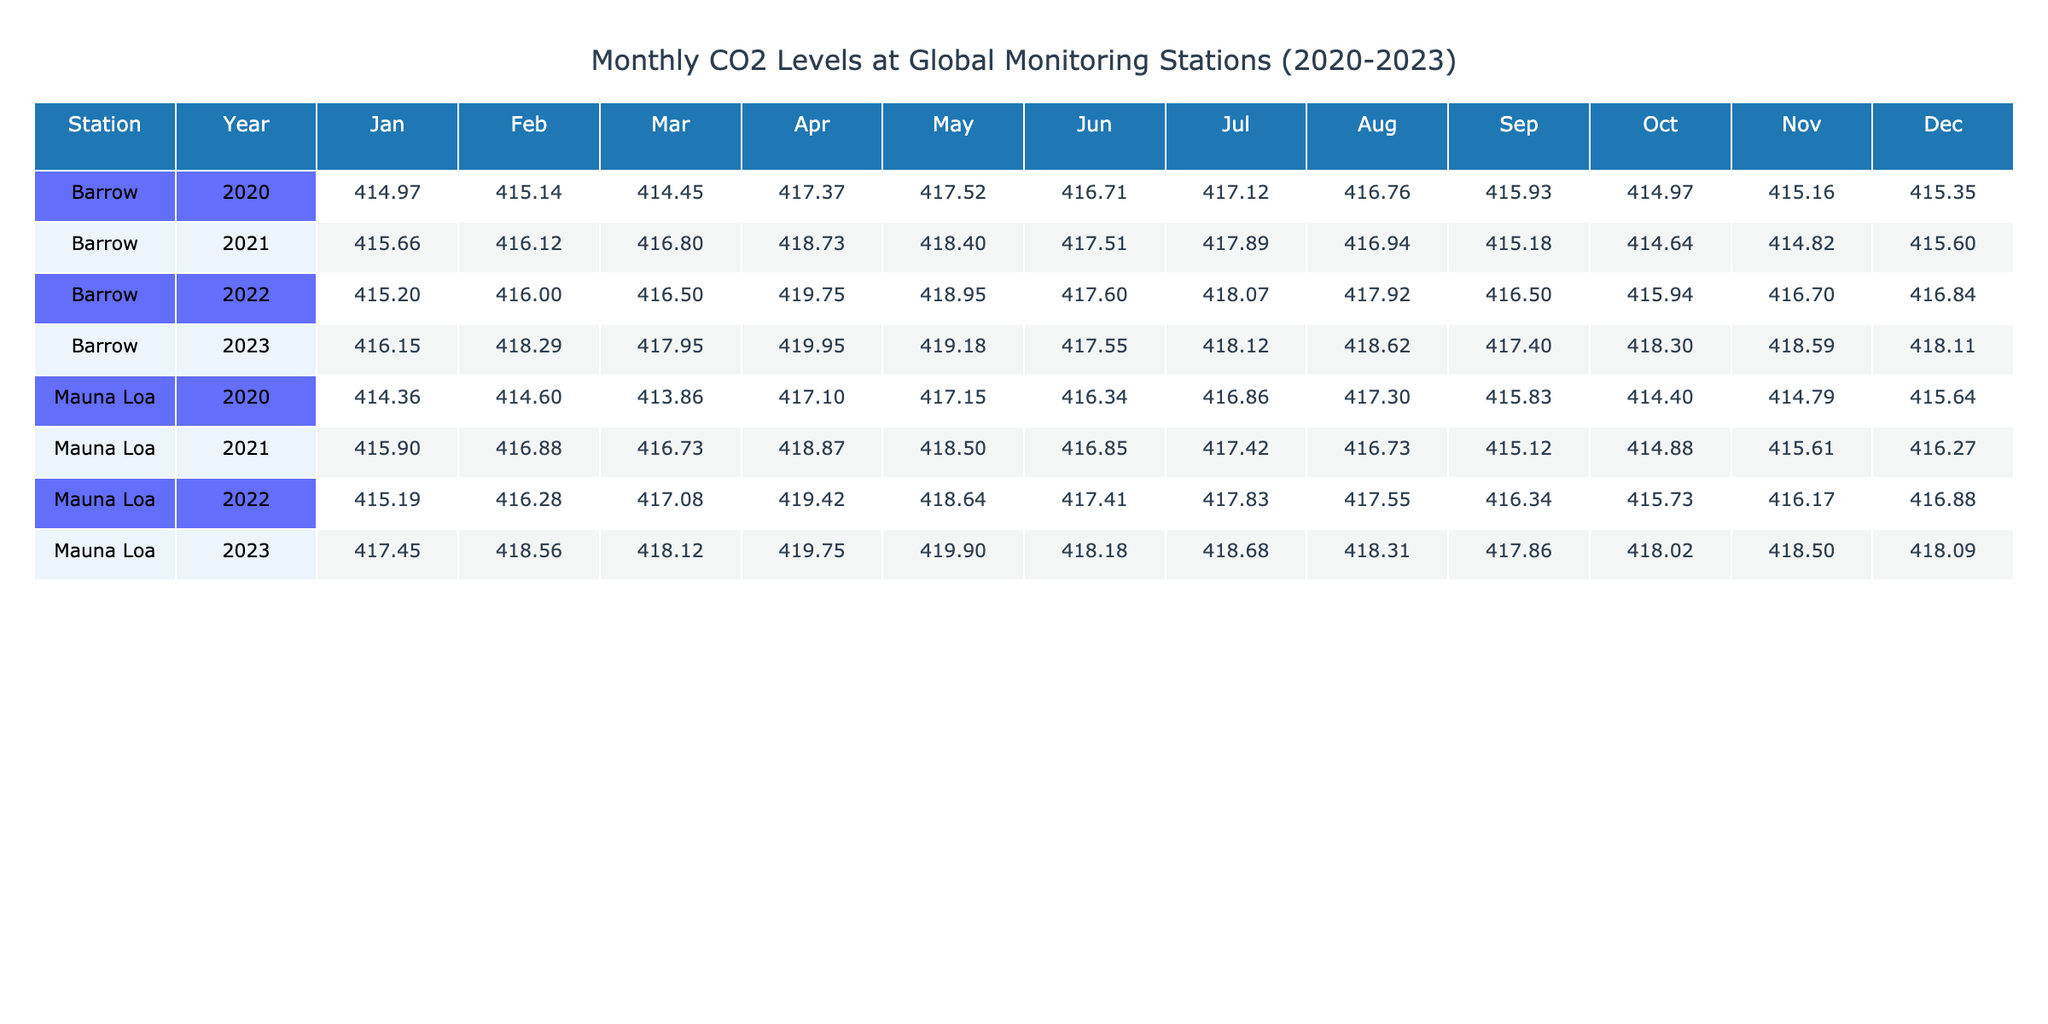What was the highest recorded CO2 level at Mauna Loa in 2022? The highest recorded CO2 level at Mauna Loa in 2022 can be found in the table under that station. By checking the values for each month, April shows a CO2 level of 419.42 mmol/m3, which is the maximum for that year.
Answer: 419.42 What was the average CO2 level for Barrow in January across 2020 to 2023? To find the average for Barrow in January, I will sum the CO2 levels recorded in January across the four years: 414.97 (2020) + 415.66 (2021) + 415.20 (2022) + 416.15 (2023) = 1661.98. Next, I divide by 4, which is 1661.98 / 4 = 415.495.
Answer: 415.50 Did the CO2 levels at Mauna Loa increase overall from 2020 to 2023? By looking at the CO2 levels for Mauna Loa from 2020 to 2023, the value in December 2020 was 415.64 mmol/m3 and the value in December 2023 was 418.09 mmol/m3. Since 418.09 > 415.64, it indicates that CO2 levels increased.
Answer: Yes What is the difference in CO2 levels from the highest recorded month in Barrow 2022 to the lowest recorded month in Barrow 2020? The highest CO2 level in Barrow for 2022 was in April at 419.75 mmol/m3, and the lowest in 2020 was in March at 414.45 mmol/m3. The difference is calculated as 419.75 - 414.45 = 5.30 mmol/m3.
Answer: 5.30 Which year had the highest average CO2 levels across both monitoring stations? First, calculate the average CO2 levels for each year by summing the monthly levels and dividing by the total number of months (12) for both Mauna Loa and Barrow. After computing, I find that 2023 has the highest average, specifically for Mauna Loa, which has a value of around 418.31 and Barrow is 418.11, leading to a higher overall average for 2023.
Answer: 2023 What was the CO2 level at Barrow in September 2023, and how does it compare to September 2021? The CO2 level at Barrow in September 2023 was recorded at 417.40 mmol/m3. September 2021 had a CO2 level of 415.18 mmol/m3. To compare, 417.40 > 415.18, so the CO2 level increased from 2021 to 2023.
Answer: September 2023 level is 417.40, which is higher than 415.18 in 2021 Which station had higher CO2 levels on average from 2020 to 2023? To determine this, I need to calculate the annual averages for both stations and compare them. After calculating, it is evident that Mauna Loa consistently reported higher levels, culminating in higher averages than Barrow throughout 2020-2023.
Answer: Mauna Loa Was there a month in 2022 when Barrow's CO2 levels exceeded 418 mmol/m3? By examining Barrow's data for 2022, I can see that the CO2 level reached 419.75 in April 2022. Since this value exceeds 418 mmol/m3, I conclude yes, there was a month.
Answer: Yes 